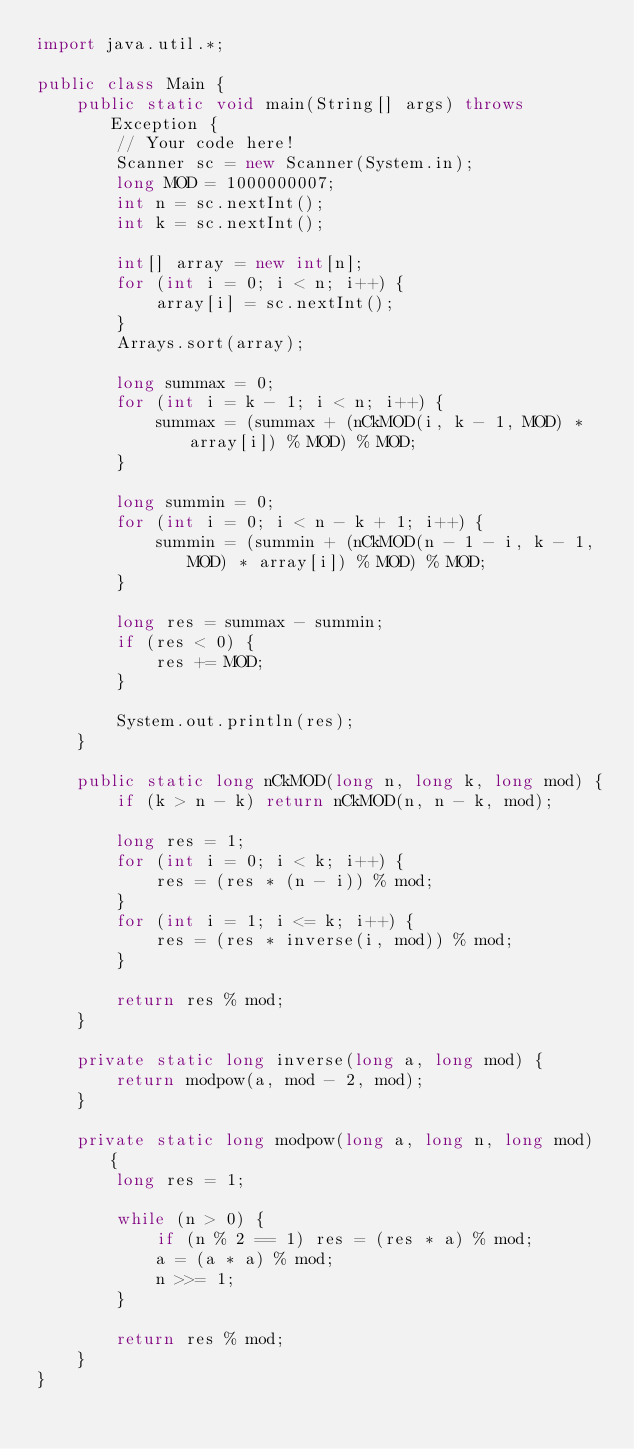<code> <loc_0><loc_0><loc_500><loc_500><_Java_>import java.util.*;

public class Main {
    public static void main(String[] args) throws Exception {
        // Your code here!
        Scanner sc = new Scanner(System.in);
        long MOD = 1000000007;
        int n = sc.nextInt();
        int k = sc.nextInt();
        
        int[] array = new int[n];
        for (int i = 0; i < n; i++) {
            array[i] = sc.nextInt();
        }
        Arrays.sort(array);
        
        long summax = 0;
        for (int i = k - 1; i < n; i++) {
            summax = (summax + (nCkMOD(i, k - 1, MOD) * array[i]) % MOD) % MOD;
        }
        
        long summin = 0;
        for (int i = 0; i < n - k + 1; i++) {
            summin = (summin + (nCkMOD(n - 1 - i, k - 1, MOD) * array[i]) % MOD) % MOD;
        }
        
        long res = summax - summin;
        if (res < 0) {
            res += MOD;
        }
        
        System.out.println(res);
    }
    
    public static long nCkMOD(long n, long k, long mod) {
        if (k > n - k) return nCkMOD(n, n - k, mod);
    
        long res = 1;
        for (int i = 0; i < k; i++) {
            res = (res * (n - i)) % mod;
        }
        for (int i = 1; i <= k; i++) {
            res = (res * inverse(i, mod)) % mod;
        }
    
        return res % mod;
    }
    
    private static long inverse(long a, long mod) {
        return modpow(a, mod - 2, mod);
    }
    
    private static long modpow(long a, long n, long mod) {
        long res = 1;
    
        while (n > 0) {
            if (n % 2 == 1) res = (res * a) % mod;
            a = (a * a) % mod;
            n >>= 1;
        }
    
        return res % mod;
    }
}
</code> 